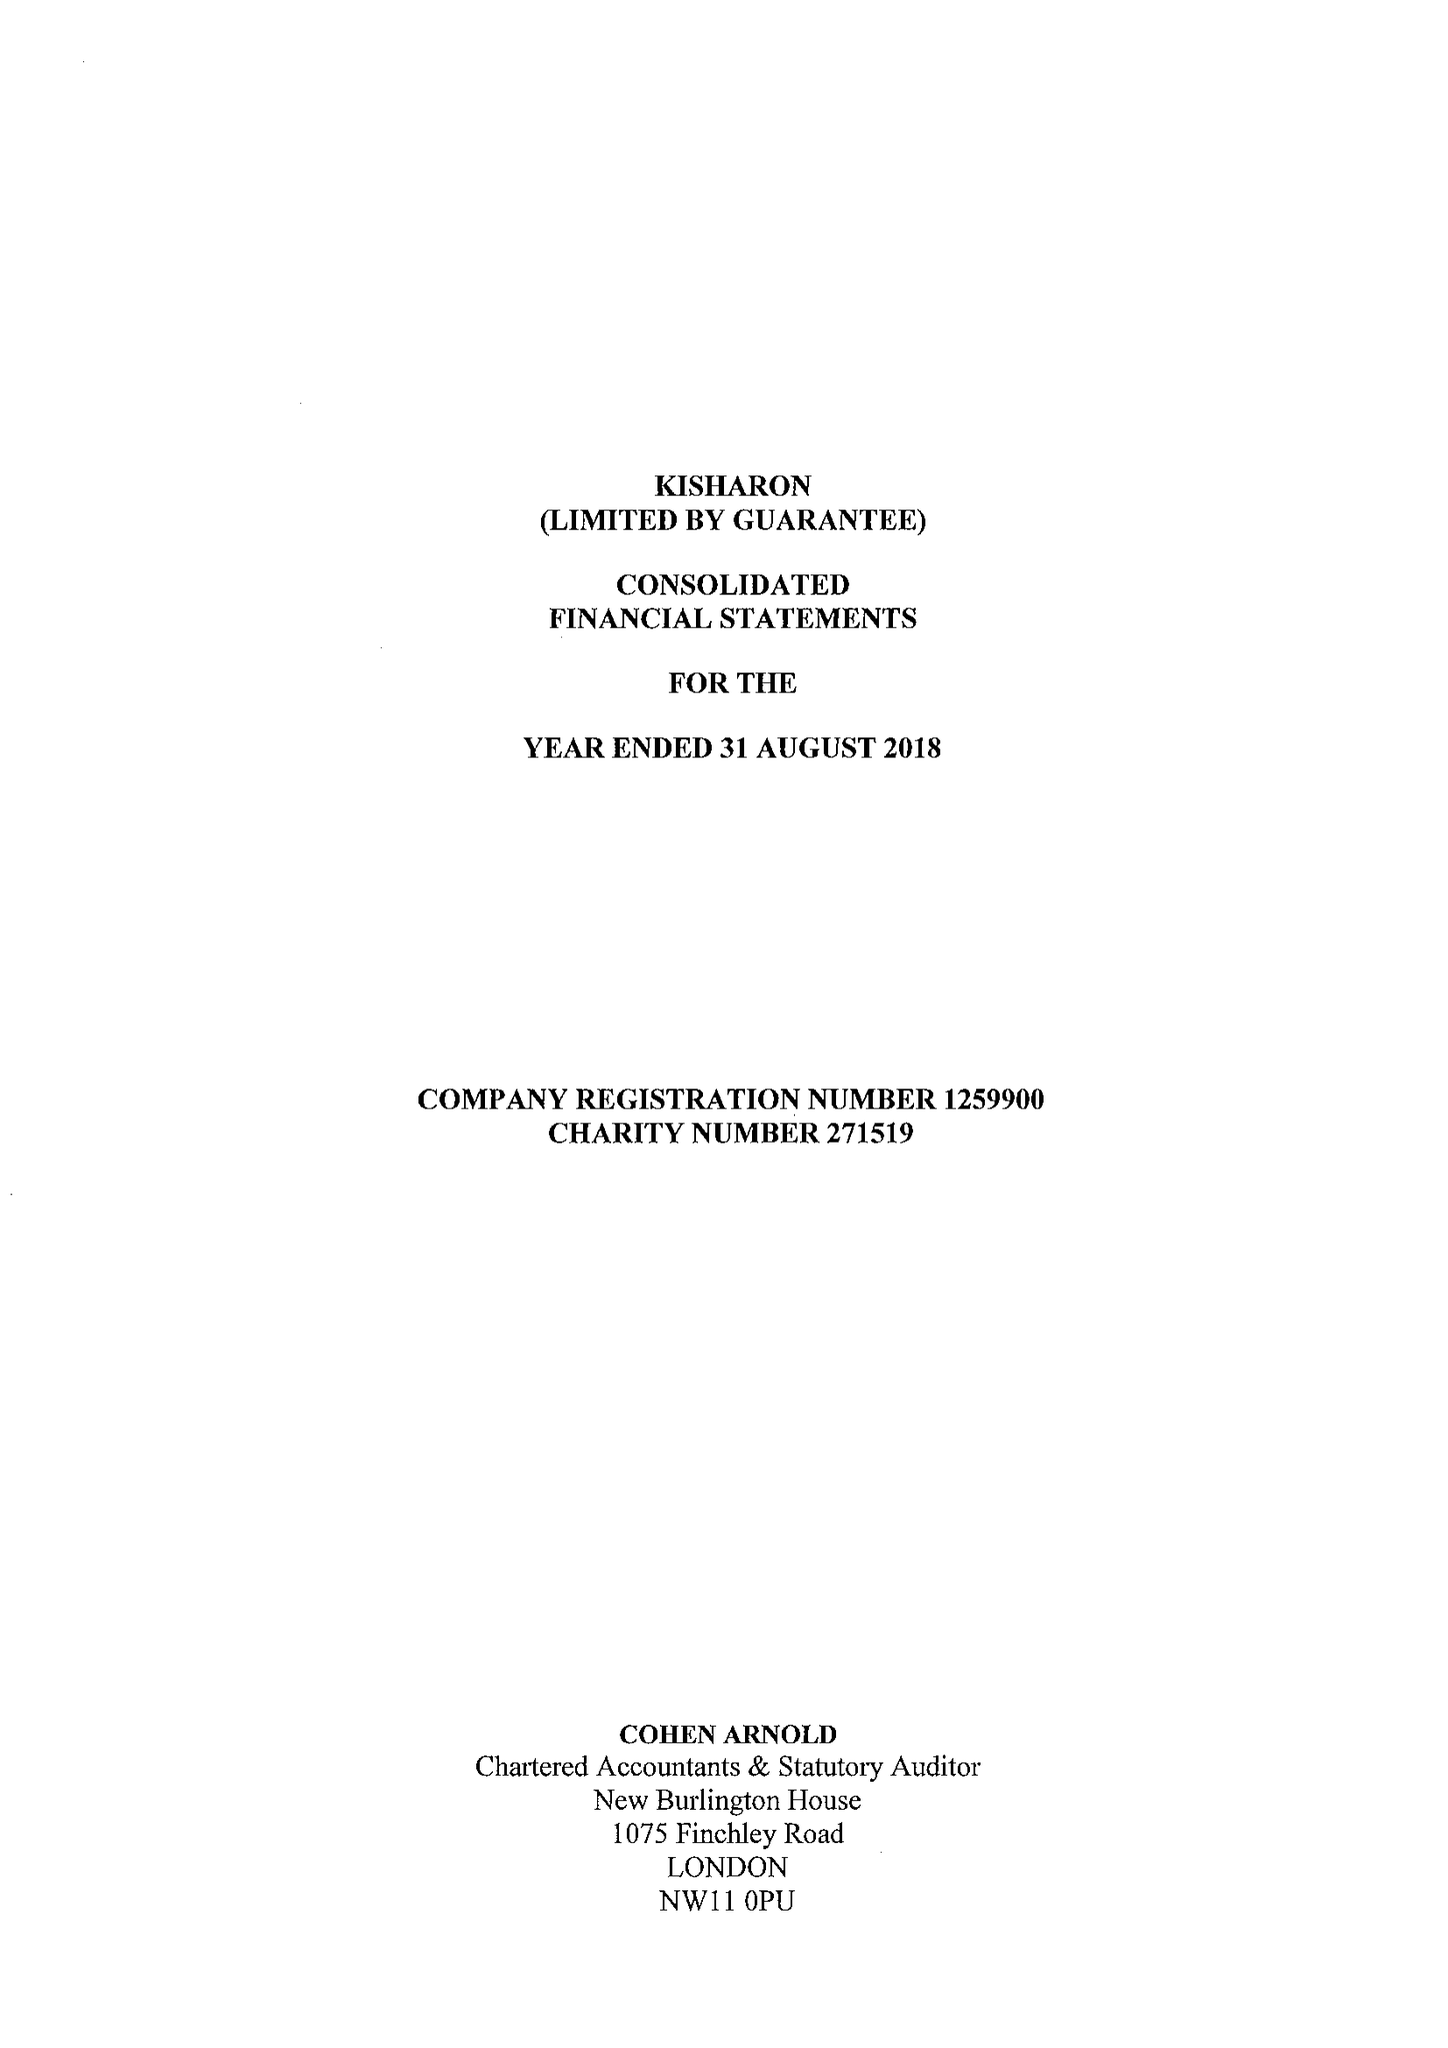What is the value for the address__street_line?
Answer the question using a single word or phrase. 333 EDGWARE ROAD 